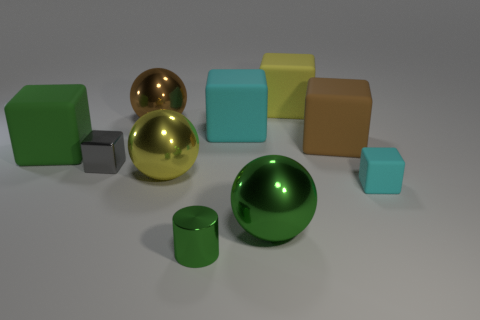Subtract all gray cylinders. How many cyan blocks are left? 2 Subtract 4 cubes. How many cubes are left? 2 Subtract all cyan blocks. How many blocks are left? 4 Subtract all large brown cubes. How many cubes are left? 5 Subtract all red cubes. Subtract all purple balls. How many cubes are left? 6 Subtract all cylinders. How many objects are left? 9 Add 5 rubber cubes. How many rubber cubes are left? 10 Add 3 big green spheres. How many big green spheres exist? 4 Subtract 1 green balls. How many objects are left? 9 Subtract all large metal spheres. Subtract all green spheres. How many objects are left? 6 